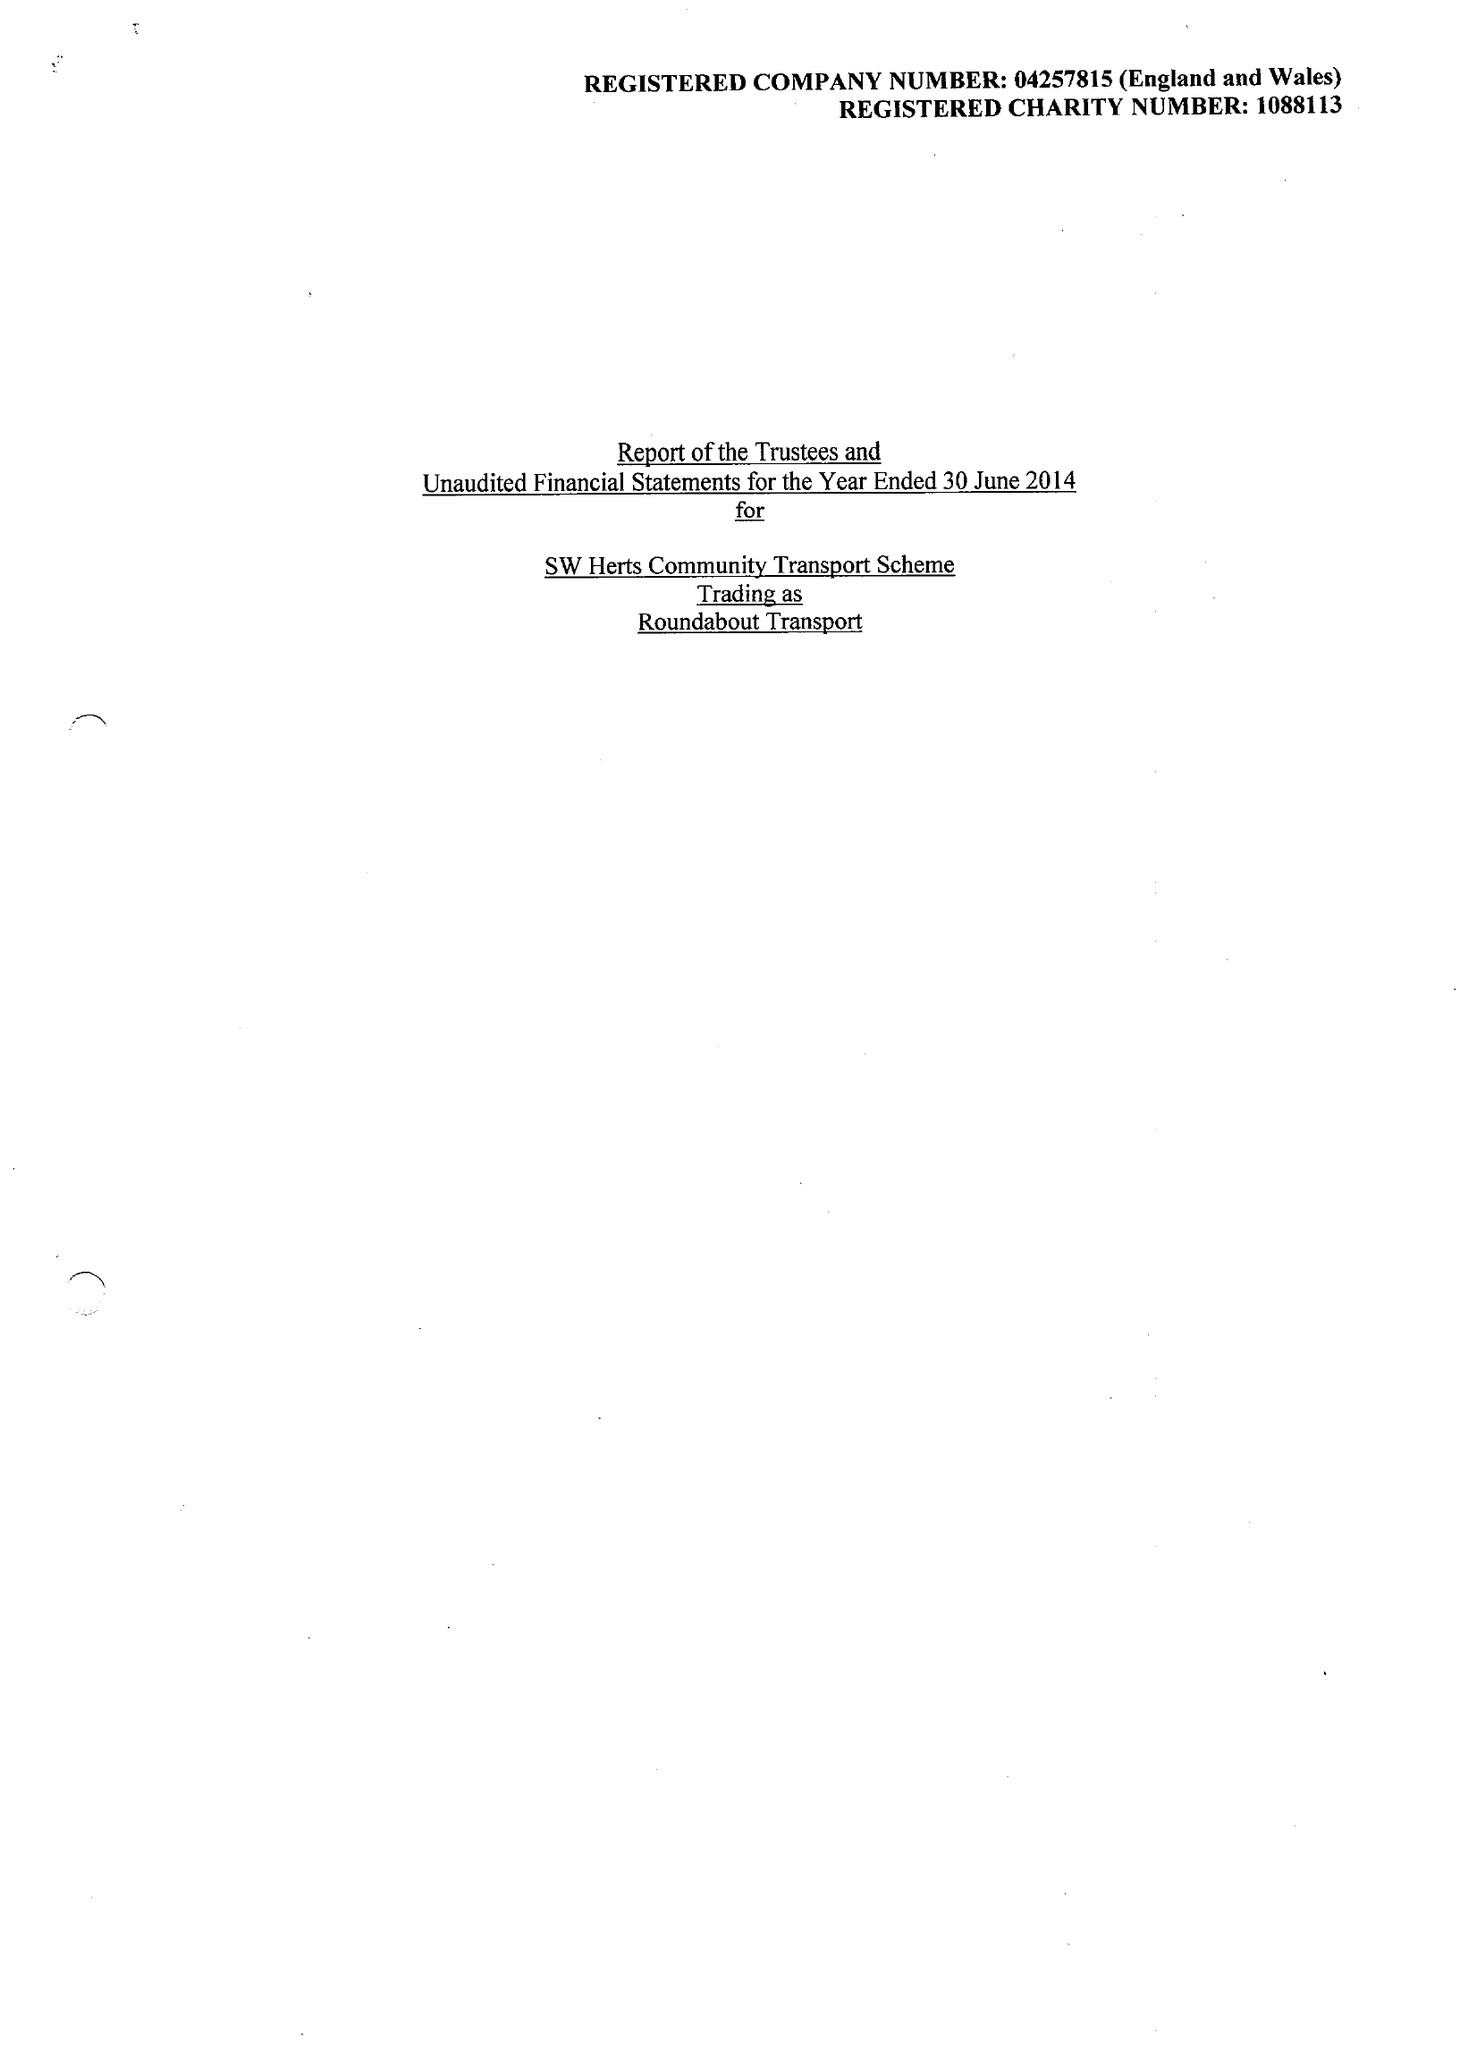What is the value for the spending_annually_in_british_pounds?
Answer the question using a single word or phrase. 133921.00 